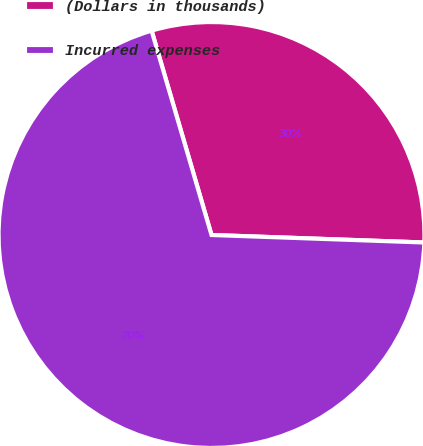<chart> <loc_0><loc_0><loc_500><loc_500><pie_chart><fcel>(Dollars in thousands)<fcel>Incurred expenses<nl><fcel>30.1%<fcel>69.9%<nl></chart> 